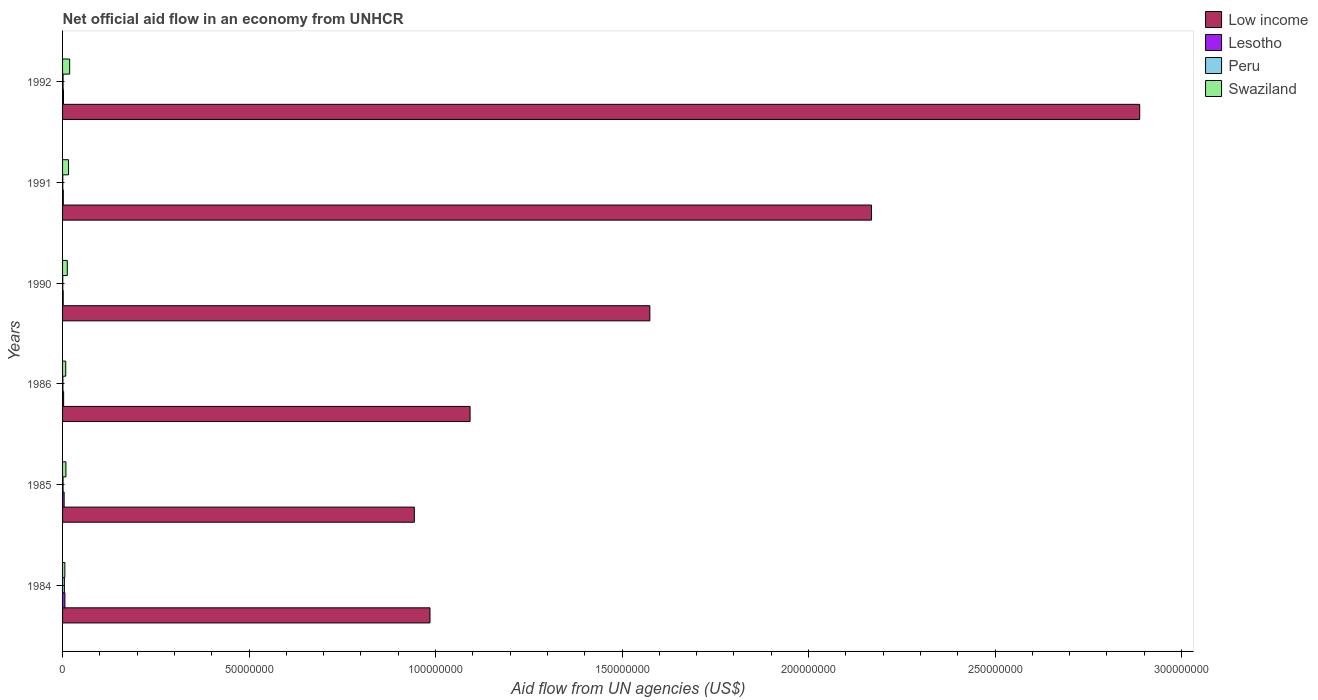Are the number of bars on each tick of the Y-axis equal?
Give a very brief answer. Yes. In how many cases, is the number of bars for a given year not equal to the number of legend labels?
Give a very brief answer. 0. What is the net official aid flow in Lesotho in 1992?
Make the answer very short. 2.50e+05. Across all years, what is the maximum net official aid flow in Lesotho?
Ensure brevity in your answer.  6.30e+05. What is the total net official aid flow in Low income in the graph?
Your response must be concise. 9.65e+08. What is the difference between the net official aid flow in Lesotho in 1984 and that in 1985?
Make the answer very short. 2.10e+05. What is the average net official aid flow in Swaziland per year?
Provide a short and direct response. 1.19e+06. In the year 1992, what is the difference between the net official aid flow in Lesotho and net official aid flow in Peru?
Provide a succinct answer. 1.10e+05. What is the ratio of the net official aid flow in Peru in 1986 to that in 1991?
Keep it short and to the point. 1.5. Is the difference between the net official aid flow in Lesotho in 1990 and 1991 greater than the difference between the net official aid flow in Peru in 1990 and 1991?
Offer a very short reply. No. What is the difference between the highest and the lowest net official aid flow in Peru?
Offer a very short reply. 4.40e+05. In how many years, is the net official aid flow in Low income greater than the average net official aid flow in Low income taken over all years?
Offer a terse response. 2. What does the 3rd bar from the top in 1991 represents?
Your response must be concise. Lesotho. Is it the case that in every year, the sum of the net official aid flow in Lesotho and net official aid flow in Swaziland is greater than the net official aid flow in Low income?
Your response must be concise. No. How many bars are there?
Offer a very short reply. 24. Are all the bars in the graph horizontal?
Offer a terse response. Yes. What is the difference between two consecutive major ticks on the X-axis?
Your answer should be compact. 5.00e+07. Does the graph contain any zero values?
Make the answer very short. No. Where does the legend appear in the graph?
Provide a succinct answer. Top right. What is the title of the graph?
Offer a terse response. Net official aid flow in an economy from UNHCR. What is the label or title of the X-axis?
Your answer should be very brief. Aid flow from UN agencies (US$). What is the label or title of the Y-axis?
Give a very brief answer. Years. What is the Aid flow from UN agencies (US$) of Low income in 1984?
Offer a very short reply. 9.85e+07. What is the Aid flow from UN agencies (US$) of Lesotho in 1984?
Offer a very short reply. 6.30e+05. What is the Aid flow from UN agencies (US$) of Low income in 1985?
Provide a succinct answer. 9.43e+07. What is the Aid flow from UN agencies (US$) of Lesotho in 1985?
Offer a very short reply. 4.20e+05. What is the Aid flow from UN agencies (US$) of Peru in 1985?
Provide a short and direct response. 1.30e+05. What is the Aid flow from UN agencies (US$) of Swaziland in 1985?
Offer a very short reply. 9.00e+05. What is the Aid flow from UN agencies (US$) of Low income in 1986?
Keep it short and to the point. 1.09e+08. What is the Aid flow from UN agencies (US$) of Swaziland in 1986?
Your response must be concise. 8.50e+05. What is the Aid flow from UN agencies (US$) of Low income in 1990?
Ensure brevity in your answer.  1.57e+08. What is the Aid flow from UN agencies (US$) of Lesotho in 1990?
Provide a succinct answer. 1.70e+05. What is the Aid flow from UN agencies (US$) of Swaziland in 1990?
Keep it short and to the point. 1.27e+06. What is the Aid flow from UN agencies (US$) of Low income in 1991?
Provide a succinct answer. 2.17e+08. What is the Aid flow from UN agencies (US$) in Peru in 1991?
Ensure brevity in your answer.  6.00e+04. What is the Aid flow from UN agencies (US$) of Swaziland in 1991?
Your answer should be very brief. 1.60e+06. What is the Aid flow from UN agencies (US$) of Low income in 1992?
Make the answer very short. 2.89e+08. What is the Aid flow from UN agencies (US$) of Lesotho in 1992?
Keep it short and to the point. 2.50e+05. What is the Aid flow from UN agencies (US$) of Peru in 1992?
Give a very brief answer. 1.40e+05. What is the Aid flow from UN agencies (US$) of Swaziland in 1992?
Provide a short and direct response. 1.90e+06. Across all years, what is the maximum Aid flow from UN agencies (US$) of Low income?
Your response must be concise. 2.89e+08. Across all years, what is the maximum Aid flow from UN agencies (US$) of Lesotho?
Give a very brief answer. 6.30e+05. Across all years, what is the maximum Aid flow from UN agencies (US$) of Swaziland?
Provide a succinct answer. 1.90e+06. Across all years, what is the minimum Aid flow from UN agencies (US$) of Low income?
Provide a short and direct response. 9.43e+07. Across all years, what is the minimum Aid flow from UN agencies (US$) of Lesotho?
Your answer should be compact. 1.70e+05. Across all years, what is the minimum Aid flow from UN agencies (US$) of Peru?
Offer a very short reply. 5.00e+04. What is the total Aid flow from UN agencies (US$) of Low income in the graph?
Keep it short and to the point. 9.65e+08. What is the total Aid flow from UN agencies (US$) in Lesotho in the graph?
Give a very brief answer. 1.96e+06. What is the total Aid flow from UN agencies (US$) of Peru in the graph?
Provide a succinct answer. 9.60e+05. What is the total Aid flow from UN agencies (US$) in Swaziland in the graph?
Keep it short and to the point. 7.13e+06. What is the difference between the Aid flow from UN agencies (US$) in Low income in 1984 and that in 1985?
Make the answer very short. 4.19e+06. What is the difference between the Aid flow from UN agencies (US$) in Lesotho in 1984 and that in 1985?
Provide a succinct answer. 2.10e+05. What is the difference between the Aid flow from UN agencies (US$) in Low income in 1984 and that in 1986?
Offer a very short reply. -1.08e+07. What is the difference between the Aid flow from UN agencies (US$) in Lesotho in 1984 and that in 1986?
Offer a very short reply. 3.40e+05. What is the difference between the Aid flow from UN agencies (US$) in Low income in 1984 and that in 1990?
Offer a terse response. -5.90e+07. What is the difference between the Aid flow from UN agencies (US$) in Lesotho in 1984 and that in 1990?
Your response must be concise. 4.60e+05. What is the difference between the Aid flow from UN agencies (US$) of Peru in 1984 and that in 1990?
Your answer should be very brief. 4.40e+05. What is the difference between the Aid flow from UN agencies (US$) of Swaziland in 1984 and that in 1990?
Your answer should be compact. -6.60e+05. What is the difference between the Aid flow from UN agencies (US$) in Low income in 1984 and that in 1991?
Make the answer very short. -1.18e+08. What is the difference between the Aid flow from UN agencies (US$) of Swaziland in 1984 and that in 1991?
Your answer should be very brief. -9.90e+05. What is the difference between the Aid flow from UN agencies (US$) of Low income in 1984 and that in 1992?
Your response must be concise. -1.90e+08. What is the difference between the Aid flow from UN agencies (US$) in Swaziland in 1984 and that in 1992?
Your answer should be very brief. -1.29e+06. What is the difference between the Aid flow from UN agencies (US$) in Low income in 1985 and that in 1986?
Provide a short and direct response. -1.49e+07. What is the difference between the Aid flow from UN agencies (US$) in Peru in 1985 and that in 1986?
Make the answer very short. 4.00e+04. What is the difference between the Aid flow from UN agencies (US$) in Low income in 1985 and that in 1990?
Keep it short and to the point. -6.31e+07. What is the difference between the Aid flow from UN agencies (US$) in Lesotho in 1985 and that in 1990?
Keep it short and to the point. 2.50e+05. What is the difference between the Aid flow from UN agencies (US$) of Swaziland in 1985 and that in 1990?
Your answer should be compact. -3.70e+05. What is the difference between the Aid flow from UN agencies (US$) of Low income in 1985 and that in 1991?
Give a very brief answer. -1.23e+08. What is the difference between the Aid flow from UN agencies (US$) of Lesotho in 1985 and that in 1991?
Keep it short and to the point. 2.20e+05. What is the difference between the Aid flow from UN agencies (US$) of Peru in 1985 and that in 1991?
Offer a terse response. 7.00e+04. What is the difference between the Aid flow from UN agencies (US$) of Swaziland in 1985 and that in 1991?
Give a very brief answer. -7.00e+05. What is the difference between the Aid flow from UN agencies (US$) of Low income in 1985 and that in 1992?
Offer a very short reply. -1.94e+08. What is the difference between the Aid flow from UN agencies (US$) in Lesotho in 1985 and that in 1992?
Provide a short and direct response. 1.70e+05. What is the difference between the Aid flow from UN agencies (US$) in Peru in 1985 and that in 1992?
Provide a succinct answer. -10000. What is the difference between the Aid flow from UN agencies (US$) in Swaziland in 1985 and that in 1992?
Keep it short and to the point. -1.00e+06. What is the difference between the Aid flow from UN agencies (US$) of Low income in 1986 and that in 1990?
Make the answer very short. -4.82e+07. What is the difference between the Aid flow from UN agencies (US$) of Peru in 1986 and that in 1990?
Make the answer very short. 4.00e+04. What is the difference between the Aid flow from UN agencies (US$) in Swaziland in 1986 and that in 1990?
Provide a short and direct response. -4.20e+05. What is the difference between the Aid flow from UN agencies (US$) of Low income in 1986 and that in 1991?
Offer a terse response. -1.08e+08. What is the difference between the Aid flow from UN agencies (US$) in Peru in 1986 and that in 1991?
Offer a very short reply. 3.00e+04. What is the difference between the Aid flow from UN agencies (US$) of Swaziland in 1986 and that in 1991?
Provide a succinct answer. -7.50e+05. What is the difference between the Aid flow from UN agencies (US$) in Low income in 1986 and that in 1992?
Keep it short and to the point. -1.80e+08. What is the difference between the Aid flow from UN agencies (US$) in Peru in 1986 and that in 1992?
Make the answer very short. -5.00e+04. What is the difference between the Aid flow from UN agencies (US$) of Swaziland in 1986 and that in 1992?
Ensure brevity in your answer.  -1.05e+06. What is the difference between the Aid flow from UN agencies (US$) of Low income in 1990 and that in 1991?
Give a very brief answer. -5.94e+07. What is the difference between the Aid flow from UN agencies (US$) in Swaziland in 1990 and that in 1991?
Ensure brevity in your answer.  -3.30e+05. What is the difference between the Aid flow from UN agencies (US$) of Low income in 1990 and that in 1992?
Offer a terse response. -1.31e+08. What is the difference between the Aid flow from UN agencies (US$) in Lesotho in 1990 and that in 1992?
Provide a succinct answer. -8.00e+04. What is the difference between the Aid flow from UN agencies (US$) of Swaziland in 1990 and that in 1992?
Ensure brevity in your answer.  -6.30e+05. What is the difference between the Aid flow from UN agencies (US$) of Low income in 1991 and that in 1992?
Your answer should be very brief. -7.19e+07. What is the difference between the Aid flow from UN agencies (US$) of Low income in 1984 and the Aid flow from UN agencies (US$) of Lesotho in 1985?
Offer a very short reply. 9.81e+07. What is the difference between the Aid flow from UN agencies (US$) in Low income in 1984 and the Aid flow from UN agencies (US$) in Peru in 1985?
Ensure brevity in your answer.  9.84e+07. What is the difference between the Aid flow from UN agencies (US$) in Low income in 1984 and the Aid flow from UN agencies (US$) in Swaziland in 1985?
Your response must be concise. 9.76e+07. What is the difference between the Aid flow from UN agencies (US$) of Lesotho in 1984 and the Aid flow from UN agencies (US$) of Peru in 1985?
Provide a short and direct response. 5.00e+05. What is the difference between the Aid flow from UN agencies (US$) of Lesotho in 1984 and the Aid flow from UN agencies (US$) of Swaziland in 1985?
Provide a short and direct response. -2.70e+05. What is the difference between the Aid flow from UN agencies (US$) of Peru in 1984 and the Aid flow from UN agencies (US$) of Swaziland in 1985?
Your response must be concise. -4.10e+05. What is the difference between the Aid flow from UN agencies (US$) in Low income in 1984 and the Aid flow from UN agencies (US$) in Lesotho in 1986?
Offer a terse response. 9.82e+07. What is the difference between the Aid flow from UN agencies (US$) of Low income in 1984 and the Aid flow from UN agencies (US$) of Peru in 1986?
Keep it short and to the point. 9.84e+07. What is the difference between the Aid flow from UN agencies (US$) of Low income in 1984 and the Aid flow from UN agencies (US$) of Swaziland in 1986?
Make the answer very short. 9.76e+07. What is the difference between the Aid flow from UN agencies (US$) in Lesotho in 1984 and the Aid flow from UN agencies (US$) in Peru in 1986?
Ensure brevity in your answer.  5.40e+05. What is the difference between the Aid flow from UN agencies (US$) of Peru in 1984 and the Aid flow from UN agencies (US$) of Swaziland in 1986?
Provide a succinct answer. -3.60e+05. What is the difference between the Aid flow from UN agencies (US$) of Low income in 1984 and the Aid flow from UN agencies (US$) of Lesotho in 1990?
Give a very brief answer. 9.83e+07. What is the difference between the Aid flow from UN agencies (US$) in Low income in 1984 and the Aid flow from UN agencies (US$) in Peru in 1990?
Your answer should be compact. 9.84e+07. What is the difference between the Aid flow from UN agencies (US$) of Low income in 1984 and the Aid flow from UN agencies (US$) of Swaziland in 1990?
Provide a succinct answer. 9.72e+07. What is the difference between the Aid flow from UN agencies (US$) of Lesotho in 1984 and the Aid flow from UN agencies (US$) of Peru in 1990?
Make the answer very short. 5.80e+05. What is the difference between the Aid flow from UN agencies (US$) in Lesotho in 1984 and the Aid flow from UN agencies (US$) in Swaziland in 1990?
Offer a terse response. -6.40e+05. What is the difference between the Aid flow from UN agencies (US$) in Peru in 1984 and the Aid flow from UN agencies (US$) in Swaziland in 1990?
Offer a terse response. -7.80e+05. What is the difference between the Aid flow from UN agencies (US$) of Low income in 1984 and the Aid flow from UN agencies (US$) of Lesotho in 1991?
Make the answer very short. 9.83e+07. What is the difference between the Aid flow from UN agencies (US$) in Low income in 1984 and the Aid flow from UN agencies (US$) in Peru in 1991?
Your answer should be compact. 9.84e+07. What is the difference between the Aid flow from UN agencies (US$) of Low income in 1984 and the Aid flow from UN agencies (US$) of Swaziland in 1991?
Offer a very short reply. 9.69e+07. What is the difference between the Aid flow from UN agencies (US$) in Lesotho in 1984 and the Aid flow from UN agencies (US$) in Peru in 1991?
Keep it short and to the point. 5.70e+05. What is the difference between the Aid flow from UN agencies (US$) in Lesotho in 1984 and the Aid flow from UN agencies (US$) in Swaziland in 1991?
Your answer should be very brief. -9.70e+05. What is the difference between the Aid flow from UN agencies (US$) of Peru in 1984 and the Aid flow from UN agencies (US$) of Swaziland in 1991?
Offer a very short reply. -1.11e+06. What is the difference between the Aid flow from UN agencies (US$) of Low income in 1984 and the Aid flow from UN agencies (US$) of Lesotho in 1992?
Your response must be concise. 9.82e+07. What is the difference between the Aid flow from UN agencies (US$) of Low income in 1984 and the Aid flow from UN agencies (US$) of Peru in 1992?
Provide a succinct answer. 9.84e+07. What is the difference between the Aid flow from UN agencies (US$) in Low income in 1984 and the Aid flow from UN agencies (US$) in Swaziland in 1992?
Provide a succinct answer. 9.66e+07. What is the difference between the Aid flow from UN agencies (US$) in Lesotho in 1984 and the Aid flow from UN agencies (US$) in Peru in 1992?
Offer a very short reply. 4.90e+05. What is the difference between the Aid flow from UN agencies (US$) of Lesotho in 1984 and the Aid flow from UN agencies (US$) of Swaziland in 1992?
Offer a terse response. -1.27e+06. What is the difference between the Aid flow from UN agencies (US$) in Peru in 1984 and the Aid flow from UN agencies (US$) in Swaziland in 1992?
Make the answer very short. -1.41e+06. What is the difference between the Aid flow from UN agencies (US$) in Low income in 1985 and the Aid flow from UN agencies (US$) in Lesotho in 1986?
Provide a short and direct response. 9.40e+07. What is the difference between the Aid flow from UN agencies (US$) of Low income in 1985 and the Aid flow from UN agencies (US$) of Peru in 1986?
Your answer should be compact. 9.42e+07. What is the difference between the Aid flow from UN agencies (US$) of Low income in 1985 and the Aid flow from UN agencies (US$) of Swaziland in 1986?
Your answer should be very brief. 9.35e+07. What is the difference between the Aid flow from UN agencies (US$) of Lesotho in 1985 and the Aid flow from UN agencies (US$) of Swaziland in 1986?
Your answer should be compact. -4.30e+05. What is the difference between the Aid flow from UN agencies (US$) of Peru in 1985 and the Aid flow from UN agencies (US$) of Swaziland in 1986?
Your answer should be compact. -7.20e+05. What is the difference between the Aid flow from UN agencies (US$) of Low income in 1985 and the Aid flow from UN agencies (US$) of Lesotho in 1990?
Provide a short and direct response. 9.41e+07. What is the difference between the Aid flow from UN agencies (US$) of Low income in 1985 and the Aid flow from UN agencies (US$) of Peru in 1990?
Offer a very short reply. 9.43e+07. What is the difference between the Aid flow from UN agencies (US$) in Low income in 1985 and the Aid flow from UN agencies (US$) in Swaziland in 1990?
Ensure brevity in your answer.  9.30e+07. What is the difference between the Aid flow from UN agencies (US$) of Lesotho in 1985 and the Aid flow from UN agencies (US$) of Swaziland in 1990?
Your answer should be compact. -8.50e+05. What is the difference between the Aid flow from UN agencies (US$) of Peru in 1985 and the Aid flow from UN agencies (US$) of Swaziland in 1990?
Offer a terse response. -1.14e+06. What is the difference between the Aid flow from UN agencies (US$) of Low income in 1985 and the Aid flow from UN agencies (US$) of Lesotho in 1991?
Your answer should be very brief. 9.41e+07. What is the difference between the Aid flow from UN agencies (US$) of Low income in 1985 and the Aid flow from UN agencies (US$) of Peru in 1991?
Keep it short and to the point. 9.42e+07. What is the difference between the Aid flow from UN agencies (US$) in Low income in 1985 and the Aid flow from UN agencies (US$) in Swaziland in 1991?
Your answer should be compact. 9.27e+07. What is the difference between the Aid flow from UN agencies (US$) of Lesotho in 1985 and the Aid flow from UN agencies (US$) of Peru in 1991?
Offer a very short reply. 3.60e+05. What is the difference between the Aid flow from UN agencies (US$) in Lesotho in 1985 and the Aid flow from UN agencies (US$) in Swaziland in 1991?
Your response must be concise. -1.18e+06. What is the difference between the Aid flow from UN agencies (US$) in Peru in 1985 and the Aid flow from UN agencies (US$) in Swaziland in 1991?
Offer a very short reply. -1.47e+06. What is the difference between the Aid flow from UN agencies (US$) of Low income in 1985 and the Aid flow from UN agencies (US$) of Lesotho in 1992?
Offer a very short reply. 9.41e+07. What is the difference between the Aid flow from UN agencies (US$) in Low income in 1985 and the Aid flow from UN agencies (US$) in Peru in 1992?
Ensure brevity in your answer.  9.42e+07. What is the difference between the Aid flow from UN agencies (US$) in Low income in 1985 and the Aid flow from UN agencies (US$) in Swaziland in 1992?
Give a very brief answer. 9.24e+07. What is the difference between the Aid flow from UN agencies (US$) of Lesotho in 1985 and the Aid flow from UN agencies (US$) of Swaziland in 1992?
Ensure brevity in your answer.  -1.48e+06. What is the difference between the Aid flow from UN agencies (US$) of Peru in 1985 and the Aid flow from UN agencies (US$) of Swaziland in 1992?
Ensure brevity in your answer.  -1.77e+06. What is the difference between the Aid flow from UN agencies (US$) in Low income in 1986 and the Aid flow from UN agencies (US$) in Lesotho in 1990?
Your answer should be very brief. 1.09e+08. What is the difference between the Aid flow from UN agencies (US$) in Low income in 1986 and the Aid flow from UN agencies (US$) in Peru in 1990?
Your answer should be compact. 1.09e+08. What is the difference between the Aid flow from UN agencies (US$) in Low income in 1986 and the Aid flow from UN agencies (US$) in Swaziland in 1990?
Provide a succinct answer. 1.08e+08. What is the difference between the Aid flow from UN agencies (US$) in Lesotho in 1986 and the Aid flow from UN agencies (US$) in Peru in 1990?
Ensure brevity in your answer.  2.40e+05. What is the difference between the Aid flow from UN agencies (US$) in Lesotho in 1986 and the Aid flow from UN agencies (US$) in Swaziland in 1990?
Provide a succinct answer. -9.80e+05. What is the difference between the Aid flow from UN agencies (US$) in Peru in 1986 and the Aid flow from UN agencies (US$) in Swaziland in 1990?
Your answer should be compact. -1.18e+06. What is the difference between the Aid flow from UN agencies (US$) of Low income in 1986 and the Aid flow from UN agencies (US$) of Lesotho in 1991?
Your answer should be compact. 1.09e+08. What is the difference between the Aid flow from UN agencies (US$) of Low income in 1986 and the Aid flow from UN agencies (US$) of Peru in 1991?
Offer a terse response. 1.09e+08. What is the difference between the Aid flow from UN agencies (US$) in Low income in 1986 and the Aid flow from UN agencies (US$) in Swaziland in 1991?
Offer a terse response. 1.08e+08. What is the difference between the Aid flow from UN agencies (US$) of Lesotho in 1986 and the Aid flow from UN agencies (US$) of Peru in 1991?
Your answer should be compact. 2.30e+05. What is the difference between the Aid flow from UN agencies (US$) in Lesotho in 1986 and the Aid flow from UN agencies (US$) in Swaziland in 1991?
Your answer should be very brief. -1.31e+06. What is the difference between the Aid flow from UN agencies (US$) in Peru in 1986 and the Aid flow from UN agencies (US$) in Swaziland in 1991?
Keep it short and to the point. -1.51e+06. What is the difference between the Aid flow from UN agencies (US$) in Low income in 1986 and the Aid flow from UN agencies (US$) in Lesotho in 1992?
Your answer should be very brief. 1.09e+08. What is the difference between the Aid flow from UN agencies (US$) of Low income in 1986 and the Aid flow from UN agencies (US$) of Peru in 1992?
Ensure brevity in your answer.  1.09e+08. What is the difference between the Aid flow from UN agencies (US$) of Low income in 1986 and the Aid flow from UN agencies (US$) of Swaziland in 1992?
Make the answer very short. 1.07e+08. What is the difference between the Aid flow from UN agencies (US$) in Lesotho in 1986 and the Aid flow from UN agencies (US$) in Peru in 1992?
Provide a succinct answer. 1.50e+05. What is the difference between the Aid flow from UN agencies (US$) of Lesotho in 1986 and the Aid flow from UN agencies (US$) of Swaziland in 1992?
Your response must be concise. -1.61e+06. What is the difference between the Aid flow from UN agencies (US$) in Peru in 1986 and the Aid flow from UN agencies (US$) in Swaziland in 1992?
Your response must be concise. -1.81e+06. What is the difference between the Aid flow from UN agencies (US$) of Low income in 1990 and the Aid flow from UN agencies (US$) of Lesotho in 1991?
Keep it short and to the point. 1.57e+08. What is the difference between the Aid flow from UN agencies (US$) in Low income in 1990 and the Aid flow from UN agencies (US$) in Peru in 1991?
Your response must be concise. 1.57e+08. What is the difference between the Aid flow from UN agencies (US$) of Low income in 1990 and the Aid flow from UN agencies (US$) of Swaziland in 1991?
Ensure brevity in your answer.  1.56e+08. What is the difference between the Aid flow from UN agencies (US$) of Lesotho in 1990 and the Aid flow from UN agencies (US$) of Peru in 1991?
Make the answer very short. 1.10e+05. What is the difference between the Aid flow from UN agencies (US$) of Lesotho in 1990 and the Aid flow from UN agencies (US$) of Swaziland in 1991?
Offer a terse response. -1.43e+06. What is the difference between the Aid flow from UN agencies (US$) in Peru in 1990 and the Aid flow from UN agencies (US$) in Swaziland in 1991?
Your response must be concise. -1.55e+06. What is the difference between the Aid flow from UN agencies (US$) of Low income in 1990 and the Aid flow from UN agencies (US$) of Lesotho in 1992?
Offer a terse response. 1.57e+08. What is the difference between the Aid flow from UN agencies (US$) in Low income in 1990 and the Aid flow from UN agencies (US$) in Peru in 1992?
Offer a very short reply. 1.57e+08. What is the difference between the Aid flow from UN agencies (US$) in Low income in 1990 and the Aid flow from UN agencies (US$) in Swaziland in 1992?
Offer a terse response. 1.56e+08. What is the difference between the Aid flow from UN agencies (US$) in Lesotho in 1990 and the Aid flow from UN agencies (US$) in Peru in 1992?
Provide a short and direct response. 3.00e+04. What is the difference between the Aid flow from UN agencies (US$) of Lesotho in 1990 and the Aid flow from UN agencies (US$) of Swaziland in 1992?
Offer a terse response. -1.73e+06. What is the difference between the Aid flow from UN agencies (US$) in Peru in 1990 and the Aid flow from UN agencies (US$) in Swaziland in 1992?
Keep it short and to the point. -1.85e+06. What is the difference between the Aid flow from UN agencies (US$) of Low income in 1991 and the Aid flow from UN agencies (US$) of Lesotho in 1992?
Your response must be concise. 2.17e+08. What is the difference between the Aid flow from UN agencies (US$) in Low income in 1991 and the Aid flow from UN agencies (US$) in Peru in 1992?
Offer a terse response. 2.17e+08. What is the difference between the Aid flow from UN agencies (US$) of Low income in 1991 and the Aid flow from UN agencies (US$) of Swaziland in 1992?
Give a very brief answer. 2.15e+08. What is the difference between the Aid flow from UN agencies (US$) of Lesotho in 1991 and the Aid flow from UN agencies (US$) of Peru in 1992?
Keep it short and to the point. 6.00e+04. What is the difference between the Aid flow from UN agencies (US$) of Lesotho in 1991 and the Aid flow from UN agencies (US$) of Swaziland in 1992?
Your response must be concise. -1.70e+06. What is the difference between the Aid flow from UN agencies (US$) of Peru in 1991 and the Aid flow from UN agencies (US$) of Swaziland in 1992?
Provide a succinct answer. -1.84e+06. What is the average Aid flow from UN agencies (US$) of Low income per year?
Your response must be concise. 1.61e+08. What is the average Aid flow from UN agencies (US$) in Lesotho per year?
Your answer should be compact. 3.27e+05. What is the average Aid flow from UN agencies (US$) of Swaziland per year?
Offer a very short reply. 1.19e+06. In the year 1984, what is the difference between the Aid flow from UN agencies (US$) of Low income and Aid flow from UN agencies (US$) of Lesotho?
Make the answer very short. 9.79e+07. In the year 1984, what is the difference between the Aid flow from UN agencies (US$) of Low income and Aid flow from UN agencies (US$) of Peru?
Ensure brevity in your answer.  9.80e+07. In the year 1984, what is the difference between the Aid flow from UN agencies (US$) of Low income and Aid flow from UN agencies (US$) of Swaziland?
Ensure brevity in your answer.  9.79e+07. In the year 1984, what is the difference between the Aid flow from UN agencies (US$) in Lesotho and Aid flow from UN agencies (US$) in Peru?
Ensure brevity in your answer.  1.40e+05. In the year 1984, what is the difference between the Aid flow from UN agencies (US$) of Lesotho and Aid flow from UN agencies (US$) of Swaziland?
Provide a short and direct response. 2.00e+04. In the year 1985, what is the difference between the Aid flow from UN agencies (US$) in Low income and Aid flow from UN agencies (US$) in Lesotho?
Offer a terse response. 9.39e+07. In the year 1985, what is the difference between the Aid flow from UN agencies (US$) of Low income and Aid flow from UN agencies (US$) of Peru?
Make the answer very short. 9.42e+07. In the year 1985, what is the difference between the Aid flow from UN agencies (US$) in Low income and Aid flow from UN agencies (US$) in Swaziland?
Your answer should be very brief. 9.34e+07. In the year 1985, what is the difference between the Aid flow from UN agencies (US$) of Lesotho and Aid flow from UN agencies (US$) of Swaziland?
Keep it short and to the point. -4.80e+05. In the year 1985, what is the difference between the Aid flow from UN agencies (US$) of Peru and Aid flow from UN agencies (US$) of Swaziland?
Offer a terse response. -7.70e+05. In the year 1986, what is the difference between the Aid flow from UN agencies (US$) in Low income and Aid flow from UN agencies (US$) in Lesotho?
Offer a terse response. 1.09e+08. In the year 1986, what is the difference between the Aid flow from UN agencies (US$) in Low income and Aid flow from UN agencies (US$) in Peru?
Offer a terse response. 1.09e+08. In the year 1986, what is the difference between the Aid flow from UN agencies (US$) of Low income and Aid flow from UN agencies (US$) of Swaziland?
Offer a terse response. 1.08e+08. In the year 1986, what is the difference between the Aid flow from UN agencies (US$) in Lesotho and Aid flow from UN agencies (US$) in Swaziland?
Your response must be concise. -5.60e+05. In the year 1986, what is the difference between the Aid flow from UN agencies (US$) of Peru and Aid flow from UN agencies (US$) of Swaziland?
Give a very brief answer. -7.60e+05. In the year 1990, what is the difference between the Aid flow from UN agencies (US$) in Low income and Aid flow from UN agencies (US$) in Lesotho?
Offer a terse response. 1.57e+08. In the year 1990, what is the difference between the Aid flow from UN agencies (US$) in Low income and Aid flow from UN agencies (US$) in Peru?
Provide a succinct answer. 1.57e+08. In the year 1990, what is the difference between the Aid flow from UN agencies (US$) of Low income and Aid flow from UN agencies (US$) of Swaziland?
Offer a terse response. 1.56e+08. In the year 1990, what is the difference between the Aid flow from UN agencies (US$) of Lesotho and Aid flow from UN agencies (US$) of Swaziland?
Provide a short and direct response. -1.10e+06. In the year 1990, what is the difference between the Aid flow from UN agencies (US$) in Peru and Aid flow from UN agencies (US$) in Swaziland?
Provide a succinct answer. -1.22e+06. In the year 1991, what is the difference between the Aid flow from UN agencies (US$) in Low income and Aid flow from UN agencies (US$) in Lesotho?
Your response must be concise. 2.17e+08. In the year 1991, what is the difference between the Aid flow from UN agencies (US$) in Low income and Aid flow from UN agencies (US$) in Peru?
Provide a succinct answer. 2.17e+08. In the year 1991, what is the difference between the Aid flow from UN agencies (US$) of Low income and Aid flow from UN agencies (US$) of Swaziland?
Make the answer very short. 2.15e+08. In the year 1991, what is the difference between the Aid flow from UN agencies (US$) of Lesotho and Aid flow from UN agencies (US$) of Swaziland?
Your response must be concise. -1.40e+06. In the year 1991, what is the difference between the Aid flow from UN agencies (US$) in Peru and Aid flow from UN agencies (US$) in Swaziland?
Make the answer very short. -1.54e+06. In the year 1992, what is the difference between the Aid flow from UN agencies (US$) of Low income and Aid flow from UN agencies (US$) of Lesotho?
Your answer should be compact. 2.89e+08. In the year 1992, what is the difference between the Aid flow from UN agencies (US$) in Low income and Aid flow from UN agencies (US$) in Peru?
Give a very brief answer. 2.89e+08. In the year 1992, what is the difference between the Aid flow from UN agencies (US$) in Low income and Aid flow from UN agencies (US$) in Swaziland?
Offer a very short reply. 2.87e+08. In the year 1992, what is the difference between the Aid flow from UN agencies (US$) of Lesotho and Aid flow from UN agencies (US$) of Swaziland?
Offer a very short reply. -1.65e+06. In the year 1992, what is the difference between the Aid flow from UN agencies (US$) of Peru and Aid flow from UN agencies (US$) of Swaziland?
Ensure brevity in your answer.  -1.76e+06. What is the ratio of the Aid flow from UN agencies (US$) in Low income in 1984 to that in 1985?
Ensure brevity in your answer.  1.04. What is the ratio of the Aid flow from UN agencies (US$) in Peru in 1984 to that in 1985?
Your response must be concise. 3.77. What is the ratio of the Aid flow from UN agencies (US$) in Swaziland in 1984 to that in 1985?
Your answer should be compact. 0.68. What is the ratio of the Aid flow from UN agencies (US$) in Low income in 1984 to that in 1986?
Your answer should be compact. 0.9. What is the ratio of the Aid flow from UN agencies (US$) in Lesotho in 1984 to that in 1986?
Your answer should be compact. 2.17. What is the ratio of the Aid flow from UN agencies (US$) of Peru in 1984 to that in 1986?
Your answer should be very brief. 5.44. What is the ratio of the Aid flow from UN agencies (US$) of Swaziland in 1984 to that in 1986?
Offer a terse response. 0.72. What is the ratio of the Aid flow from UN agencies (US$) in Low income in 1984 to that in 1990?
Offer a very short reply. 0.63. What is the ratio of the Aid flow from UN agencies (US$) in Lesotho in 1984 to that in 1990?
Provide a succinct answer. 3.71. What is the ratio of the Aid flow from UN agencies (US$) in Swaziland in 1984 to that in 1990?
Provide a succinct answer. 0.48. What is the ratio of the Aid flow from UN agencies (US$) of Low income in 1984 to that in 1991?
Keep it short and to the point. 0.45. What is the ratio of the Aid flow from UN agencies (US$) of Lesotho in 1984 to that in 1991?
Give a very brief answer. 3.15. What is the ratio of the Aid flow from UN agencies (US$) of Peru in 1984 to that in 1991?
Ensure brevity in your answer.  8.17. What is the ratio of the Aid flow from UN agencies (US$) in Swaziland in 1984 to that in 1991?
Make the answer very short. 0.38. What is the ratio of the Aid flow from UN agencies (US$) in Low income in 1984 to that in 1992?
Your answer should be very brief. 0.34. What is the ratio of the Aid flow from UN agencies (US$) of Lesotho in 1984 to that in 1992?
Provide a succinct answer. 2.52. What is the ratio of the Aid flow from UN agencies (US$) of Swaziland in 1984 to that in 1992?
Make the answer very short. 0.32. What is the ratio of the Aid flow from UN agencies (US$) of Low income in 1985 to that in 1986?
Give a very brief answer. 0.86. What is the ratio of the Aid flow from UN agencies (US$) of Lesotho in 1985 to that in 1986?
Provide a short and direct response. 1.45. What is the ratio of the Aid flow from UN agencies (US$) in Peru in 1985 to that in 1986?
Provide a short and direct response. 1.44. What is the ratio of the Aid flow from UN agencies (US$) of Swaziland in 1985 to that in 1986?
Give a very brief answer. 1.06. What is the ratio of the Aid flow from UN agencies (US$) in Low income in 1985 to that in 1990?
Offer a terse response. 0.6. What is the ratio of the Aid flow from UN agencies (US$) in Lesotho in 1985 to that in 1990?
Your response must be concise. 2.47. What is the ratio of the Aid flow from UN agencies (US$) in Peru in 1985 to that in 1990?
Your answer should be compact. 2.6. What is the ratio of the Aid flow from UN agencies (US$) in Swaziland in 1985 to that in 1990?
Offer a terse response. 0.71. What is the ratio of the Aid flow from UN agencies (US$) in Low income in 1985 to that in 1991?
Your response must be concise. 0.43. What is the ratio of the Aid flow from UN agencies (US$) of Peru in 1985 to that in 1991?
Provide a short and direct response. 2.17. What is the ratio of the Aid flow from UN agencies (US$) in Swaziland in 1985 to that in 1991?
Provide a short and direct response. 0.56. What is the ratio of the Aid flow from UN agencies (US$) in Low income in 1985 to that in 1992?
Your response must be concise. 0.33. What is the ratio of the Aid flow from UN agencies (US$) of Lesotho in 1985 to that in 1992?
Ensure brevity in your answer.  1.68. What is the ratio of the Aid flow from UN agencies (US$) of Peru in 1985 to that in 1992?
Offer a terse response. 0.93. What is the ratio of the Aid flow from UN agencies (US$) in Swaziland in 1985 to that in 1992?
Keep it short and to the point. 0.47. What is the ratio of the Aid flow from UN agencies (US$) in Low income in 1986 to that in 1990?
Your response must be concise. 0.69. What is the ratio of the Aid flow from UN agencies (US$) of Lesotho in 1986 to that in 1990?
Offer a terse response. 1.71. What is the ratio of the Aid flow from UN agencies (US$) of Peru in 1986 to that in 1990?
Your response must be concise. 1.8. What is the ratio of the Aid flow from UN agencies (US$) of Swaziland in 1986 to that in 1990?
Ensure brevity in your answer.  0.67. What is the ratio of the Aid flow from UN agencies (US$) in Low income in 1986 to that in 1991?
Keep it short and to the point. 0.5. What is the ratio of the Aid flow from UN agencies (US$) in Lesotho in 1986 to that in 1991?
Your answer should be compact. 1.45. What is the ratio of the Aid flow from UN agencies (US$) in Peru in 1986 to that in 1991?
Offer a terse response. 1.5. What is the ratio of the Aid flow from UN agencies (US$) in Swaziland in 1986 to that in 1991?
Give a very brief answer. 0.53. What is the ratio of the Aid flow from UN agencies (US$) of Low income in 1986 to that in 1992?
Ensure brevity in your answer.  0.38. What is the ratio of the Aid flow from UN agencies (US$) of Lesotho in 1986 to that in 1992?
Provide a succinct answer. 1.16. What is the ratio of the Aid flow from UN agencies (US$) in Peru in 1986 to that in 1992?
Your response must be concise. 0.64. What is the ratio of the Aid flow from UN agencies (US$) in Swaziland in 1986 to that in 1992?
Your response must be concise. 0.45. What is the ratio of the Aid flow from UN agencies (US$) of Low income in 1990 to that in 1991?
Offer a terse response. 0.73. What is the ratio of the Aid flow from UN agencies (US$) in Lesotho in 1990 to that in 1991?
Provide a short and direct response. 0.85. What is the ratio of the Aid flow from UN agencies (US$) of Swaziland in 1990 to that in 1991?
Provide a short and direct response. 0.79. What is the ratio of the Aid flow from UN agencies (US$) of Low income in 1990 to that in 1992?
Your answer should be compact. 0.55. What is the ratio of the Aid flow from UN agencies (US$) in Lesotho in 1990 to that in 1992?
Ensure brevity in your answer.  0.68. What is the ratio of the Aid flow from UN agencies (US$) of Peru in 1990 to that in 1992?
Provide a succinct answer. 0.36. What is the ratio of the Aid flow from UN agencies (US$) in Swaziland in 1990 to that in 1992?
Your response must be concise. 0.67. What is the ratio of the Aid flow from UN agencies (US$) in Low income in 1991 to that in 1992?
Ensure brevity in your answer.  0.75. What is the ratio of the Aid flow from UN agencies (US$) of Lesotho in 1991 to that in 1992?
Offer a very short reply. 0.8. What is the ratio of the Aid flow from UN agencies (US$) in Peru in 1991 to that in 1992?
Offer a very short reply. 0.43. What is the ratio of the Aid flow from UN agencies (US$) of Swaziland in 1991 to that in 1992?
Offer a terse response. 0.84. What is the difference between the highest and the second highest Aid flow from UN agencies (US$) of Low income?
Make the answer very short. 7.19e+07. What is the difference between the highest and the second highest Aid flow from UN agencies (US$) of Lesotho?
Ensure brevity in your answer.  2.10e+05. What is the difference between the highest and the lowest Aid flow from UN agencies (US$) of Low income?
Your answer should be compact. 1.94e+08. What is the difference between the highest and the lowest Aid flow from UN agencies (US$) of Lesotho?
Provide a short and direct response. 4.60e+05. What is the difference between the highest and the lowest Aid flow from UN agencies (US$) in Peru?
Your answer should be very brief. 4.40e+05. What is the difference between the highest and the lowest Aid flow from UN agencies (US$) in Swaziland?
Give a very brief answer. 1.29e+06. 